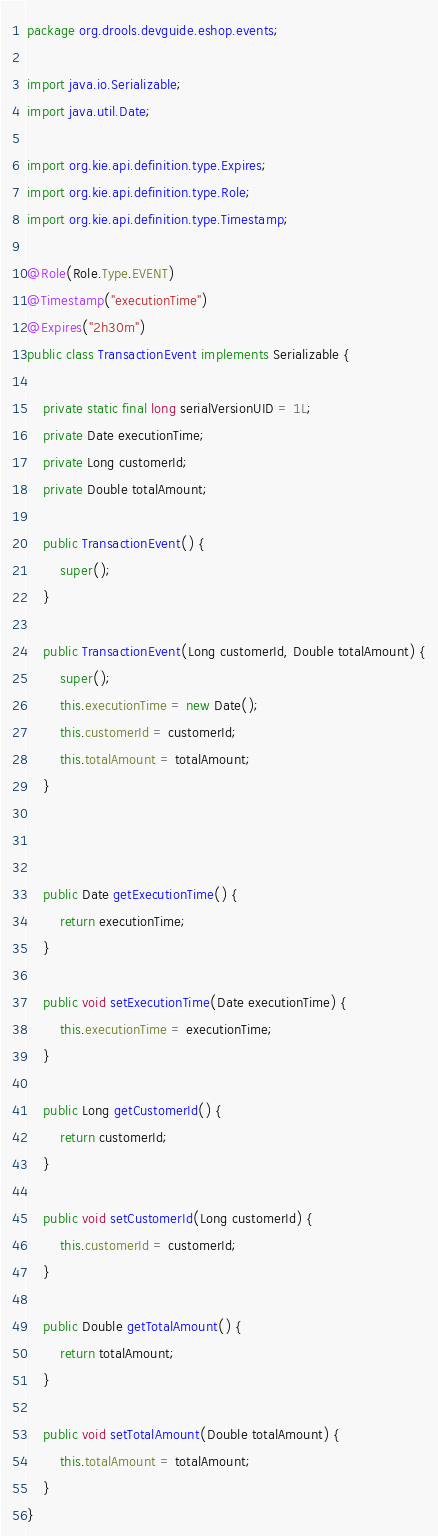Convert code to text. <code><loc_0><loc_0><loc_500><loc_500><_Java_>package org.drools.devguide.eshop.events;

import java.io.Serializable;
import java.util.Date;

import org.kie.api.definition.type.Expires;
import org.kie.api.definition.type.Role;
import org.kie.api.definition.type.Timestamp;

@Role(Role.Type.EVENT)
@Timestamp("executionTime")
@Expires("2h30m")
public class TransactionEvent implements Serializable {

    private static final long serialVersionUID = 1L;
    private Date executionTime;
    private Long customerId;
    private Double totalAmount;

    public TransactionEvent() {
        super();
    }
    
    public TransactionEvent(Long customerId, Double totalAmount) {
        super();
        this.executionTime = new Date();
        this.customerId = customerId;
        this.totalAmount = totalAmount;
    }



    public Date getExecutionTime() {
        return executionTime;
    }

    public void setExecutionTime(Date executionTime) {
        this.executionTime = executionTime;
    }

    public Long getCustomerId() {
        return customerId;
    }

    public void setCustomerId(Long customerId) {
        this.customerId = customerId;
    }

    public Double getTotalAmount() {
        return totalAmount;
    }

    public void setTotalAmount(Double totalAmount) {
        this.totalAmount = totalAmount;
    }
}

</code> 